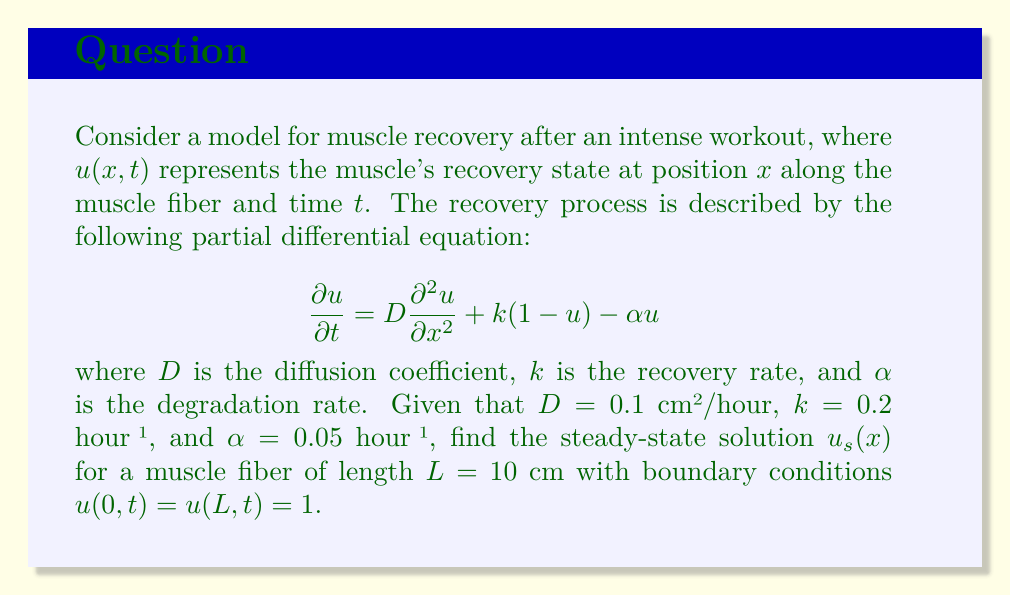Show me your answer to this math problem. To find the steady-state solution, we need to solve the equation when $\frac{\partial u}{\partial t} = 0$. This gives us:

$$0 = D\frac{d^2 u_s}{dx^2} + k(1-u_s) - \alpha u_s$$

Rearranging the terms:

$$D\frac{d^2 u_s}{dx^2} - (k+\alpha)u_s + k = 0$$

This is a second-order linear differential equation. Let's define $\beta^2 = \frac{k+\alpha}{D}$. The general solution is:

$$u_s(x) = A\cosh(\beta x) + B\sinh(\beta x) + \frac{k}{k+\alpha}$$

Using the boundary conditions:

1) At $x = 0$: $u_s(0) = 1 = A + \frac{k}{k+\alpha}$
   $A = 1 - \frac{k}{k+\alpha} = \frac{\alpha}{k+\alpha}$

2) At $x = L$: $u_s(L) = 1 = A\cosh(\beta L) + B\sinh(\beta L) + \frac{k}{k+\alpha}$

Substituting the value of $A$ and solving for $B$:

$$B = \frac{1 - \frac{k}{k+\alpha} - \frac{\alpha}{k+\alpha}\cosh(\beta L)}{\sinh(\beta L)}$$

Now, let's calculate the numerical values:

$\beta^2 = \frac{0.2 + 0.05}{0.1} = 2.5$ cm⁻²
$\beta = \sqrt{2.5} \approx 1.5811$ cm⁻¹

$A = \frac{0.05}{0.2 + 0.05} = 0.2$

$B = \frac{1 - \frac{0.2}{0.25} - 0.2\cosh(15.811)}{sinh(15.811)} \approx -0.2$

Therefore, the steady-state solution is:

$$u_s(x) = 0.2\cosh(1.5811x) - 0.2\sinh(1.5811x) + 0.8$$
Answer: The steady-state solution is:
$$u_s(x) = 0.2\cosh(1.5811x) - 0.2\sinh(1.5811x) + 0.8$$
where $x$ is measured in centimeters. 